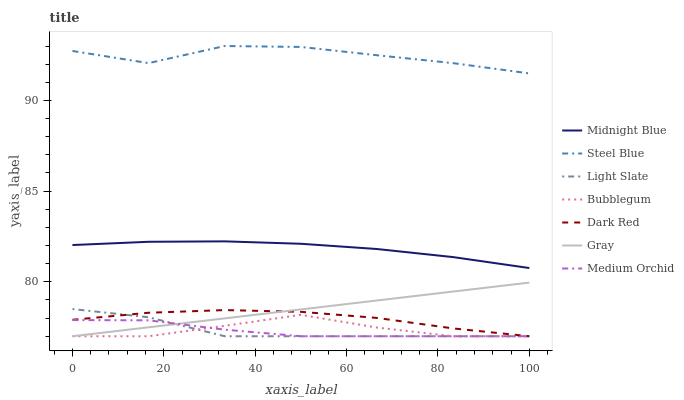Does Medium Orchid have the minimum area under the curve?
Answer yes or no. Yes. Does Steel Blue have the maximum area under the curve?
Answer yes or no. Yes. Does Midnight Blue have the minimum area under the curve?
Answer yes or no. No. Does Midnight Blue have the maximum area under the curve?
Answer yes or no. No. Is Gray the smoothest?
Answer yes or no. Yes. Is Steel Blue the roughest?
Answer yes or no. Yes. Is Midnight Blue the smoothest?
Answer yes or no. No. Is Midnight Blue the roughest?
Answer yes or no. No. Does Gray have the lowest value?
Answer yes or no. Yes. Does Midnight Blue have the lowest value?
Answer yes or no. No. Does Steel Blue have the highest value?
Answer yes or no. Yes. Does Midnight Blue have the highest value?
Answer yes or no. No. Is Medium Orchid less than Midnight Blue?
Answer yes or no. Yes. Is Steel Blue greater than Gray?
Answer yes or no. Yes. Does Dark Red intersect Gray?
Answer yes or no. Yes. Is Dark Red less than Gray?
Answer yes or no. No. Is Dark Red greater than Gray?
Answer yes or no. No. Does Medium Orchid intersect Midnight Blue?
Answer yes or no. No. 